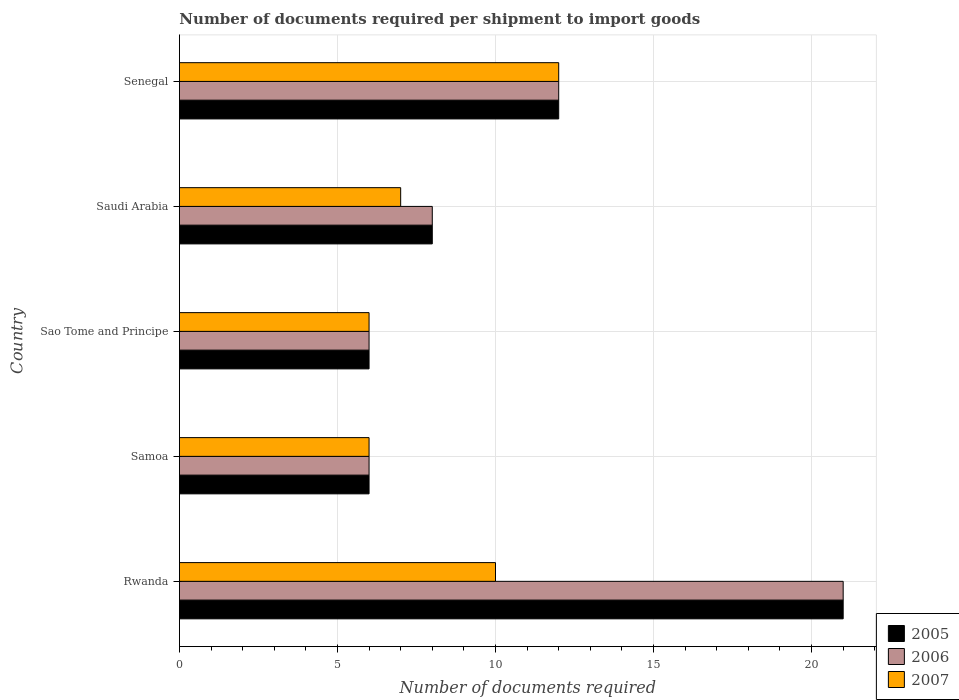How many different coloured bars are there?
Provide a short and direct response. 3. How many groups of bars are there?
Your answer should be very brief. 5. Are the number of bars per tick equal to the number of legend labels?
Make the answer very short. Yes. Are the number of bars on each tick of the Y-axis equal?
Offer a terse response. Yes. How many bars are there on the 3rd tick from the top?
Provide a succinct answer. 3. What is the label of the 5th group of bars from the top?
Your answer should be very brief. Rwanda. Across all countries, what is the maximum number of documents required per shipment to import goods in 2005?
Provide a short and direct response. 21. Across all countries, what is the minimum number of documents required per shipment to import goods in 2006?
Your response must be concise. 6. In which country was the number of documents required per shipment to import goods in 2007 maximum?
Your answer should be very brief. Senegal. In which country was the number of documents required per shipment to import goods in 2007 minimum?
Your answer should be very brief. Samoa. What is the total number of documents required per shipment to import goods in 2005 in the graph?
Give a very brief answer. 53. What is the difference between the number of documents required per shipment to import goods in 2006 in Rwanda and that in Saudi Arabia?
Keep it short and to the point. 13. What is the average number of documents required per shipment to import goods in 2005 per country?
Keep it short and to the point. 10.6. What is the difference between the number of documents required per shipment to import goods in 2005 and number of documents required per shipment to import goods in 2006 in Senegal?
Your response must be concise. 0. In how many countries, is the number of documents required per shipment to import goods in 2007 greater than 4 ?
Your response must be concise. 5. What is the ratio of the number of documents required per shipment to import goods in 2005 in Sao Tome and Principe to that in Saudi Arabia?
Provide a succinct answer. 0.75. Is the difference between the number of documents required per shipment to import goods in 2005 in Rwanda and Sao Tome and Principe greater than the difference between the number of documents required per shipment to import goods in 2006 in Rwanda and Sao Tome and Principe?
Your response must be concise. No. What is the difference between the highest and the second highest number of documents required per shipment to import goods in 2005?
Provide a succinct answer. 9. What is the difference between the highest and the lowest number of documents required per shipment to import goods in 2006?
Offer a very short reply. 15. In how many countries, is the number of documents required per shipment to import goods in 2007 greater than the average number of documents required per shipment to import goods in 2007 taken over all countries?
Provide a succinct answer. 2. Is the sum of the number of documents required per shipment to import goods in 2007 in Saudi Arabia and Senegal greater than the maximum number of documents required per shipment to import goods in 2006 across all countries?
Your answer should be very brief. No. What does the 2nd bar from the bottom in Saudi Arabia represents?
Keep it short and to the point. 2006. What is the difference between two consecutive major ticks on the X-axis?
Ensure brevity in your answer.  5. Where does the legend appear in the graph?
Make the answer very short. Bottom right. What is the title of the graph?
Offer a terse response. Number of documents required per shipment to import goods. What is the label or title of the X-axis?
Make the answer very short. Number of documents required. What is the label or title of the Y-axis?
Provide a succinct answer. Country. What is the Number of documents required in 2005 in Rwanda?
Provide a succinct answer. 21. What is the Number of documents required of 2006 in Rwanda?
Keep it short and to the point. 21. What is the Number of documents required of 2005 in Samoa?
Your answer should be compact. 6. What is the Number of documents required in 2005 in Sao Tome and Principe?
Your response must be concise. 6. What is the Number of documents required in 2007 in Sao Tome and Principe?
Ensure brevity in your answer.  6. What is the Number of documents required of 2005 in Saudi Arabia?
Keep it short and to the point. 8. What is the Number of documents required of 2007 in Saudi Arabia?
Ensure brevity in your answer.  7. What is the Number of documents required in 2005 in Senegal?
Provide a succinct answer. 12. What is the Number of documents required in 2006 in Senegal?
Ensure brevity in your answer.  12. What is the Number of documents required of 2007 in Senegal?
Make the answer very short. 12. Across all countries, what is the maximum Number of documents required of 2005?
Make the answer very short. 21. Across all countries, what is the minimum Number of documents required in 2007?
Provide a short and direct response. 6. What is the total Number of documents required of 2005 in the graph?
Give a very brief answer. 53. What is the total Number of documents required of 2006 in the graph?
Ensure brevity in your answer.  53. What is the difference between the Number of documents required of 2005 in Rwanda and that in Samoa?
Provide a succinct answer. 15. What is the difference between the Number of documents required of 2006 in Rwanda and that in Samoa?
Your answer should be compact. 15. What is the difference between the Number of documents required in 2005 in Rwanda and that in Sao Tome and Principe?
Offer a terse response. 15. What is the difference between the Number of documents required of 2006 in Rwanda and that in Sao Tome and Principe?
Make the answer very short. 15. What is the difference between the Number of documents required of 2005 in Rwanda and that in Saudi Arabia?
Your response must be concise. 13. What is the difference between the Number of documents required of 2006 in Rwanda and that in Saudi Arabia?
Your answer should be compact. 13. What is the difference between the Number of documents required of 2007 in Rwanda and that in Saudi Arabia?
Keep it short and to the point. 3. What is the difference between the Number of documents required in 2005 in Rwanda and that in Senegal?
Provide a succinct answer. 9. What is the difference between the Number of documents required of 2005 in Samoa and that in Sao Tome and Principe?
Offer a terse response. 0. What is the difference between the Number of documents required of 2006 in Samoa and that in Sao Tome and Principe?
Provide a succinct answer. 0. What is the difference between the Number of documents required in 2005 in Samoa and that in Senegal?
Offer a very short reply. -6. What is the difference between the Number of documents required of 2006 in Samoa and that in Senegal?
Keep it short and to the point. -6. What is the difference between the Number of documents required in 2007 in Samoa and that in Senegal?
Keep it short and to the point. -6. What is the difference between the Number of documents required of 2006 in Sao Tome and Principe and that in Saudi Arabia?
Your response must be concise. -2. What is the difference between the Number of documents required in 2007 in Sao Tome and Principe and that in Senegal?
Offer a terse response. -6. What is the difference between the Number of documents required in 2005 in Rwanda and the Number of documents required in 2006 in Samoa?
Ensure brevity in your answer.  15. What is the difference between the Number of documents required of 2005 in Rwanda and the Number of documents required of 2007 in Sao Tome and Principe?
Provide a succinct answer. 15. What is the difference between the Number of documents required in 2006 in Rwanda and the Number of documents required in 2007 in Sao Tome and Principe?
Ensure brevity in your answer.  15. What is the difference between the Number of documents required of 2006 in Rwanda and the Number of documents required of 2007 in Saudi Arabia?
Your response must be concise. 14. What is the difference between the Number of documents required of 2005 in Rwanda and the Number of documents required of 2006 in Senegal?
Your response must be concise. 9. What is the difference between the Number of documents required in 2005 in Samoa and the Number of documents required in 2006 in Sao Tome and Principe?
Provide a succinct answer. 0. What is the difference between the Number of documents required in 2006 in Samoa and the Number of documents required in 2007 in Sao Tome and Principe?
Make the answer very short. 0. What is the difference between the Number of documents required of 2005 in Samoa and the Number of documents required of 2006 in Saudi Arabia?
Give a very brief answer. -2. What is the difference between the Number of documents required of 2005 in Sao Tome and Principe and the Number of documents required of 2006 in Saudi Arabia?
Offer a very short reply. -2. What is the difference between the Number of documents required of 2005 in Sao Tome and Principe and the Number of documents required of 2007 in Saudi Arabia?
Give a very brief answer. -1. What is the difference between the Number of documents required in 2005 in Sao Tome and Principe and the Number of documents required in 2006 in Senegal?
Provide a short and direct response. -6. What is the difference between the Number of documents required of 2005 in Sao Tome and Principe and the Number of documents required of 2007 in Senegal?
Give a very brief answer. -6. What is the difference between the Number of documents required of 2006 in Sao Tome and Principe and the Number of documents required of 2007 in Senegal?
Your answer should be very brief. -6. What is the difference between the Number of documents required of 2005 in Saudi Arabia and the Number of documents required of 2006 in Senegal?
Make the answer very short. -4. What is the difference between the Number of documents required in 2005 in Saudi Arabia and the Number of documents required in 2007 in Senegal?
Keep it short and to the point. -4. What is the difference between the Number of documents required of 2006 in Saudi Arabia and the Number of documents required of 2007 in Senegal?
Provide a succinct answer. -4. What is the average Number of documents required in 2007 per country?
Your answer should be very brief. 8.2. What is the difference between the Number of documents required in 2005 and Number of documents required in 2006 in Rwanda?
Ensure brevity in your answer.  0. What is the difference between the Number of documents required in 2006 and Number of documents required in 2007 in Rwanda?
Provide a short and direct response. 11. What is the difference between the Number of documents required in 2006 and Number of documents required in 2007 in Samoa?
Offer a terse response. 0. What is the difference between the Number of documents required of 2005 and Number of documents required of 2006 in Sao Tome and Principe?
Provide a short and direct response. 0. What is the difference between the Number of documents required in 2005 and Number of documents required in 2007 in Saudi Arabia?
Provide a succinct answer. 1. What is the ratio of the Number of documents required of 2005 in Rwanda to that in Samoa?
Your response must be concise. 3.5. What is the ratio of the Number of documents required in 2005 in Rwanda to that in Sao Tome and Principe?
Your response must be concise. 3.5. What is the ratio of the Number of documents required in 2005 in Rwanda to that in Saudi Arabia?
Ensure brevity in your answer.  2.62. What is the ratio of the Number of documents required in 2006 in Rwanda to that in Saudi Arabia?
Your response must be concise. 2.62. What is the ratio of the Number of documents required in 2007 in Rwanda to that in Saudi Arabia?
Provide a succinct answer. 1.43. What is the ratio of the Number of documents required in 2006 in Rwanda to that in Senegal?
Make the answer very short. 1.75. What is the ratio of the Number of documents required in 2007 in Samoa to that in Sao Tome and Principe?
Your answer should be very brief. 1. What is the ratio of the Number of documents required in 2005 in Samoa to that in Saudi Arabia?
Make the answer very short. 0.75. What is the ratio of the Number of documents required of 2006 in Samoa to that in Saudi Arabia?
Ensure brevity in your answer.  0.75. What is the ratio of the Number of documents required in 2007 in Samoa to that in Saudi Arabia?
Offer a very short reply. 0.86. What is the ratio of the Number of documents required in 2005 in Samoa to that in Senegal?
Provide a short and direct response. 0.5. What is the ratio of the Number of documents required in 2006 in Samoa to that in Senegal?
Your answer should be very brief. 0.5. What is the ratio of the Number of documents required of 2006 in Sao Tome and Principe to that in Saudi Arabia?
Keep it short and to the point. 0.75. What is the ratio of the Number of documents required in 2007 in Sao Tome and Principe to that in Saudi Arabia?
Make the answer very short. 0.86. What is the ratio of the Number of documents required of 2005 in Sao Tome and Principe to that in Senegal?
Provide a succinct answer. 0.5. What is the ratio of the Number of documents required in 2006 in Sao Tome and Principe to that in Senegal?
Make the answer very short. 0.5. What is the ratio of the Number of documents required in 2007 in Saudi Arabia to that in Senegal?
Your answer should be very brief. 0.58. What is the difference between the highest and the second highest Number of documents required of 2005?
Offer a very short reply. 9. What is the difference between the highest and the second highest Number of documents required of 2006?
Offer a terse response. 9. What is the difference between the highest and the second highest Number of documents required in 2007?
Provide a succinct answer. 2. 